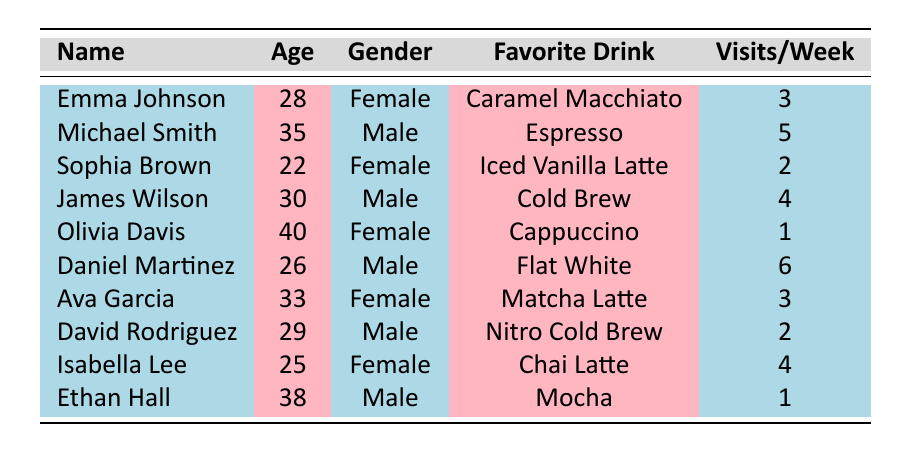What's the favorite drink of Emma Johnson? Emma Johnson is listed in the table with her favorite drink specified as "Caramel Macchiato".
Answer: Caramel Macchiato How many times a week does Daniel Martinez visit the coffee shop? The table shows that Daniel Martinez visits the coffee shop 6 times per week.
Answer: 6 Is Olivia Davis more likely to visit the shop than David Rodriguez? Olivia Davis visits the shop 1 time per week while David Rodriguez visits 2 times per week. Therefore, Olivia is less likely to visit than David.
Answer: No What is the average visit frequency per week for all customers? The visit frequencies for all customers are: 3, 5, 2, 4, 1, 6, 3, 2, 4, 1. Summing these values gives 31, and there are 10 customers, so the average is 31/10 = 3.1.
Answer: 3.1 Who has the highest visit frequency and what is their favorite drink? Scanning the visit frequency column, Daniel Martinez has the highest frequency at 6 visits per week, and his favorite drink is "Flat White".
Answer: Daniel Martinez, Flat White Are there more female customers than male customers in the table? The table shows 5 females (Emma, Sophia, Olivia, Ava, Isabella) and 5 males (Michael, James, Daniel, David, Ethan). There is an equal number of both genders.
Answer: No What is the favorite drink of the youngest customer? The youngest customer is Sophia Brown, who is 22 years old, and her favorite drink is "Iced Vanilla Latte".
Answer: Iced Vanilla Latte What is the median age of the customers? The ages of the customers are: 22, 25, 26, 28, 29, 30, 33, 35, 38, 40. When sorted, the middle two ages (29 and 30) yield the median age when averaged: (29 + 30) / 2 = 29.5.
Answer: 29.5 How many customers have a favorite drink that is either a latte or a brew? The favorite drinks considered are: Caramel Macchiato, Espresso, Iced Vanilla Latte, Cold Brew, Cappuccino, Flat White, Matcha Latte, Nitro Cold Brew, Chai Latte, Mocha. The drinks that match are: Iced Vanilla Latte, Cold Brew, Flat White, Matcha Latte, Nitro Cold Brew, Chai Latte. There are 6 customers with these preferences.
Answer: 6 